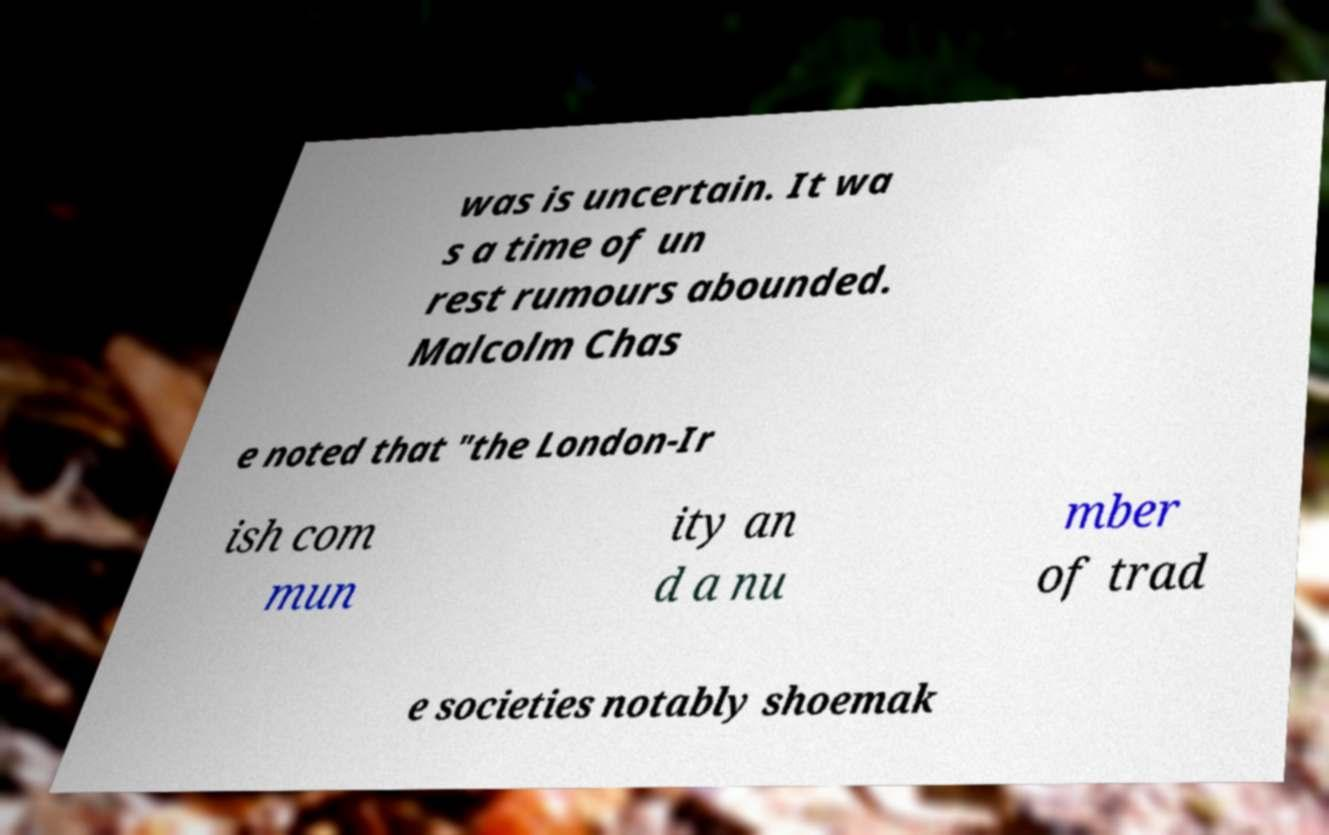What messages or text are displayed in this image? I need them in a readable, typed format. was is uncertain. It wa s a time of un rest rumours abounded. Malcolm Chas e noted that "the London-Ir ish com mun ity an d a nu mber of trad e societies notably shoemak 